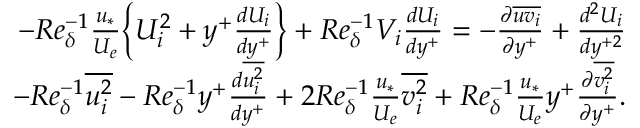<formula> <loc_0><loc_0><loc_500><loc_500>\begin{array} { r } { - R e _ { \delta } ^ { - 1 } \frac { u _ { * } } { U _ { e } } \left \{ U _ { i } ^ { 2 } + y ^ { + } \frac { d U _ { i } } { d y ^ { + } } \right \} + R e _ { \delta } ^ { - 1 } V _ { i } \frac { d U _ { i } } { d y ^ { + } } = - \frac { \partial \overline { { u v _ { i } } } } { \partial y ^ { + } } + \frac { d ^ { 2 } U _ { i } } { d y ^ { + 2 } } } \\ { - R e _ { \delta } ^ { - 1 } \overline { { u _ { i } ^ { 2 } } } - R e _ { \delta } ^ { - 1 } y ^ { + } \frac { d \overline { { u _ { i } ^ { 2 } } } } { d y ^ { + } } + 2 R e _ { \delta } ^ { - 1 } \frac { u _ { * } } { U _ { e } } \overline { { v _ { i } ^ { 2 } } } + R e _ { \delta } ^ { - 1 } \frac { u _ { * } } { U _ { e } } y ^ { + } \frac { \partial \overline { { v _ { i } ^ { 2 } } } } { \partial y ^ { + } } . } \end{array}</formula> 